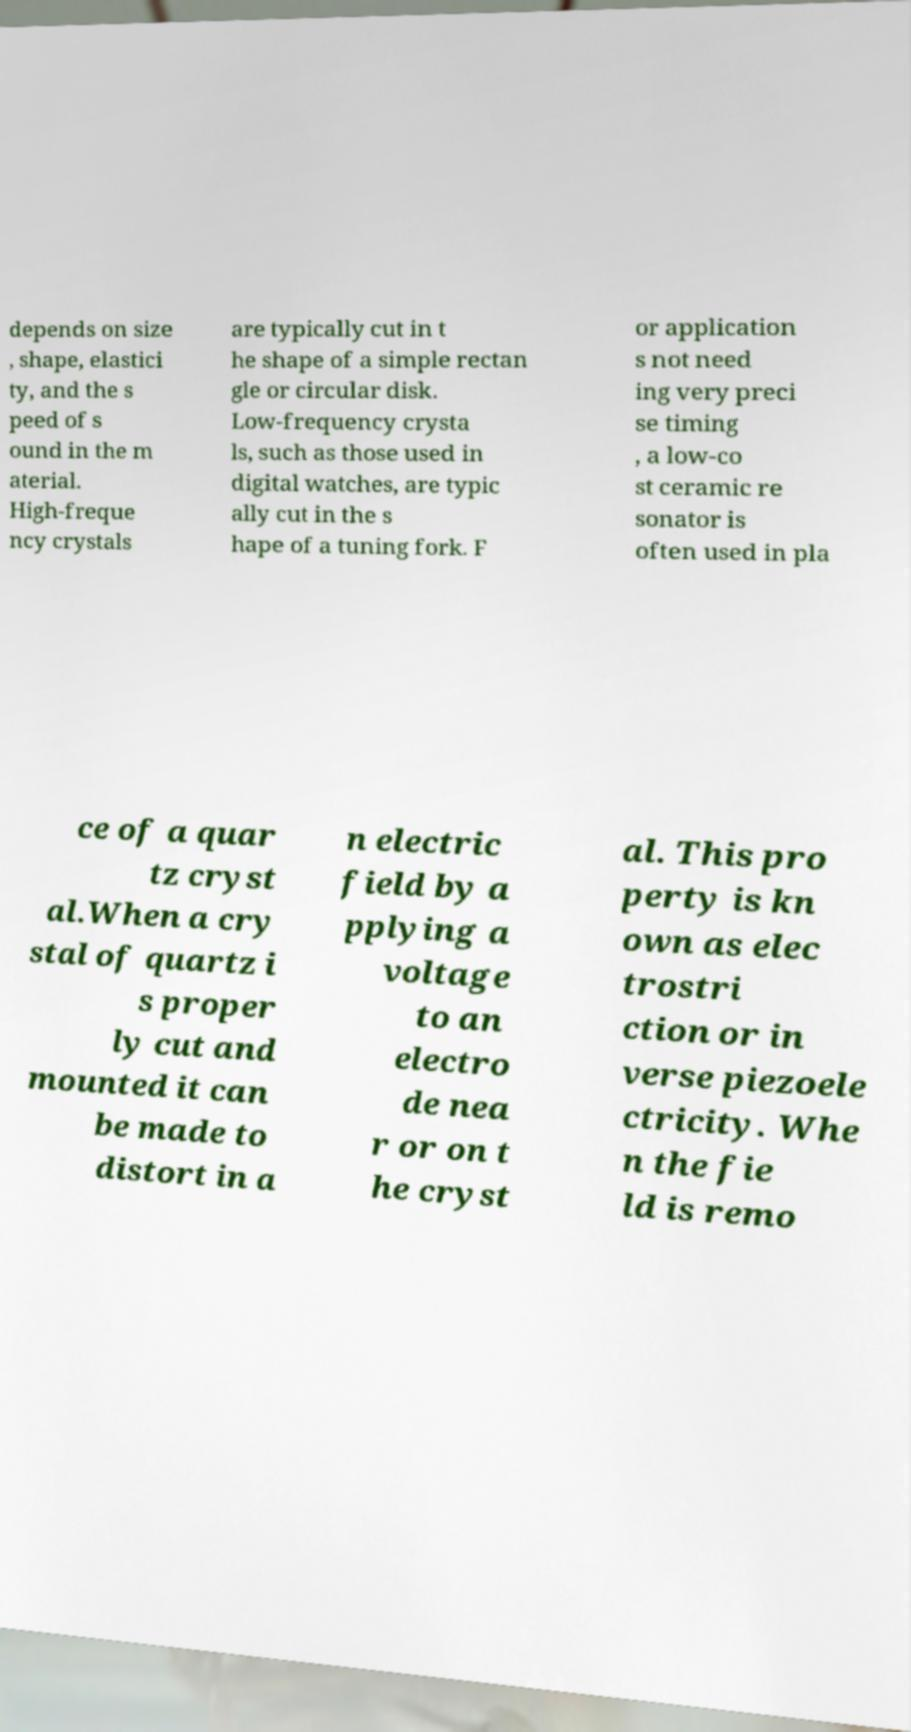I need the written content from this picture converted into text. Can you do that? depends on size , shape, elastici ty, and the s peed of s ound in the m aterial. High-freque ncy crystals are typically cut in t he shape of a simple rectan gle or circular disk. Low-frequency crysta ls, such as those used in digital watches, are typic ally cut in the s hape of a tuning fork. F or application s not need ing very preci se timing , a low-co st ceramic re sonator is often used in pla ce of a quar tz cryst al.When a cry stal of quartz i s proper ly cut and mounted it can be made to distort in a n electric field by a pplying a voltage to an electro de nea r or on t he cryst al. This pro perty is kn own as elec trostri ction or in verse piezoele ctricity. Whe n the fie ld is remo 